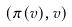Convert formula to latex. <formula><loc_0><loc_0><loc_500><loc_500>( \pi ( v ) , v )</formula> 